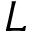Convert formula to latex. <formula><loc_0><loc_0><loc_500><loc_500>L</formula> 